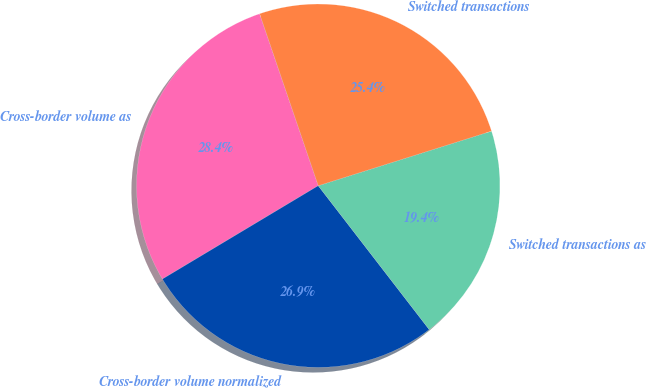Convert chart. <chart><loc_0><loc_0><loc_500><loc_500><pie_chart><fcel>Cross-border volume as<fcel>Cross-border volume normalized<fcel>Switched transactions as<fcel>Switched transactions<nl><fcel>28.36%<fcel>26.87%<fcel>19.4%<fcel>25.37%<nl></chart> 